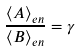Convert formula to latex. <formula><loc_0><loc_0><loc_500><loc_500>\frac { \langle A \rangle _ { e n } } { \langle B \rangle _ { e n } } = \gamma</formula> 